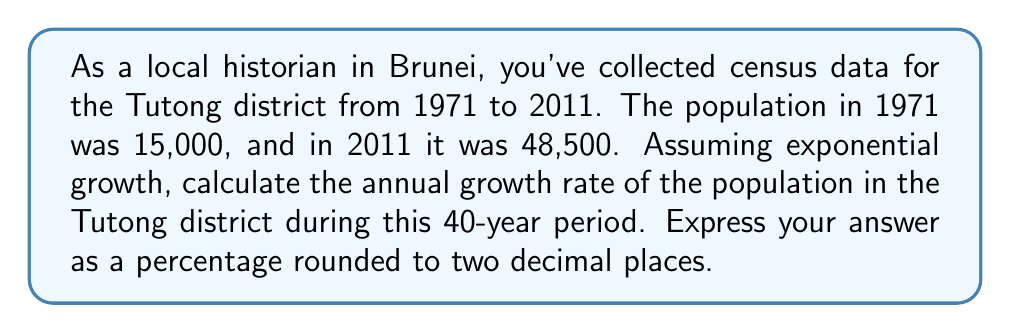Provide a solution to this math problem. To solve this problem, we'll use the exponential growth formula:

$$A = P(1 + r)^t$$

Where:
$A$ = Final amount (population in 2011)
$P$ = Initial amount (population in 1971)
$r$ = Annual growth rate (what we're solving for)
$t$ = Time period in years

Given:
$A = 48,500$
$P = 15,000$
$t = 40$ years

Let's substitute these values into the formula:

$$48,500 = 15,000(1 + r)^{40}$$

Now, let's solve for $r$:

1) Divide both sides by 15,000:
   $$\frac{48,500}{15,000} = (1 + r)^{40}$$
   $$3.2333 = (1 + r)^{40}$$

2) Take the 40th root of both sides:
   $$\sqrt[40]{3.2333} = 1 + r$$
   $$1.0298 = 1 + r$$

3) Subtract 1 from both sides:
   $$0.0298 = r$$

4) Convert to a percentage:
   $$r = 0.0298 \times 100 = 2.98\%$$

5) Round to two decimal places:
   $$r \approx 2.98\%$$

Therefore, the annual growth rate of the population in the Tutong district from 1971 to 2011 was approximately 2.98%.
Answer: 2.98% 